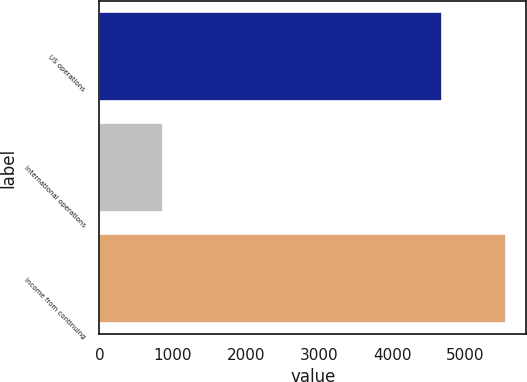Convert chart. <chart><loc_0><loc_0><loc_500><loc_500><bar_chart><fcel>US operations<fcel>International operations<fcel>Income from continuing<nl><fcel>4677<fcel>875<fcel>5552<nl></chart> 